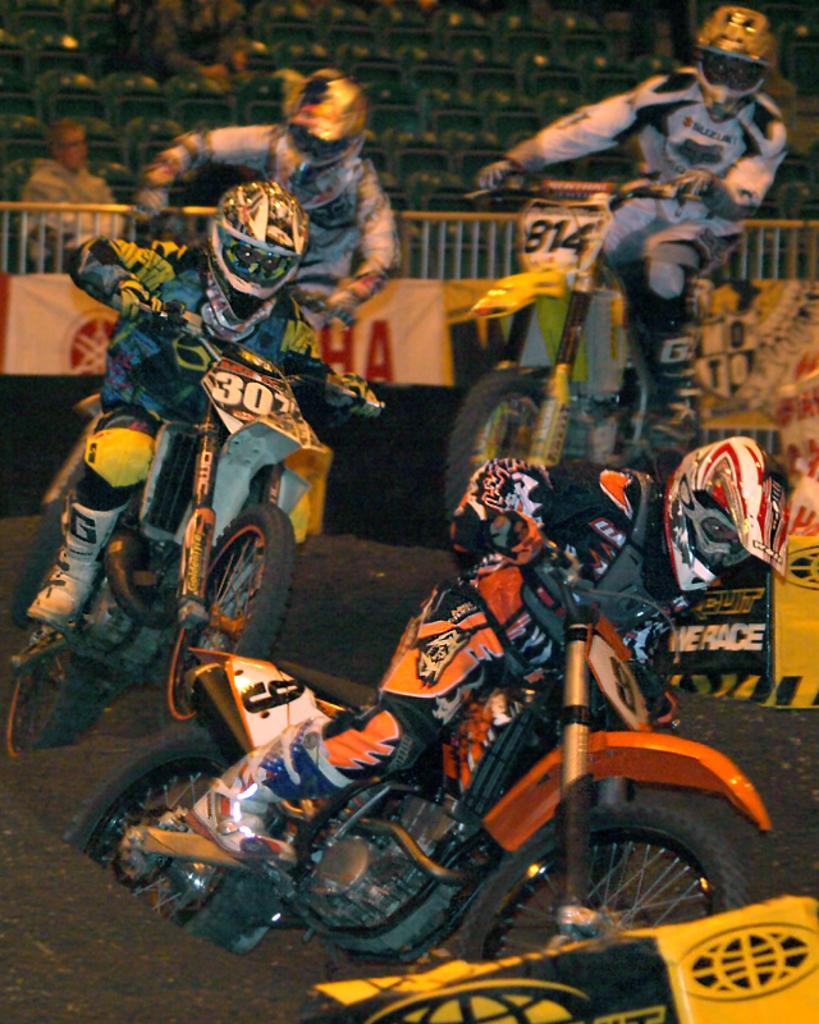Can you describe this image briefly? In this image we can see some persons, vehicles, sand and other objects. In the background of the image there are banners, railing, persons and other objects. 